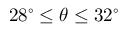Convert formula to latex. <formula><loc_0><loc_0><loc_500><loc_500>2 8 ^ { \circ } \leq \theta \leq 3 2 ^ { \circ }</formula> 